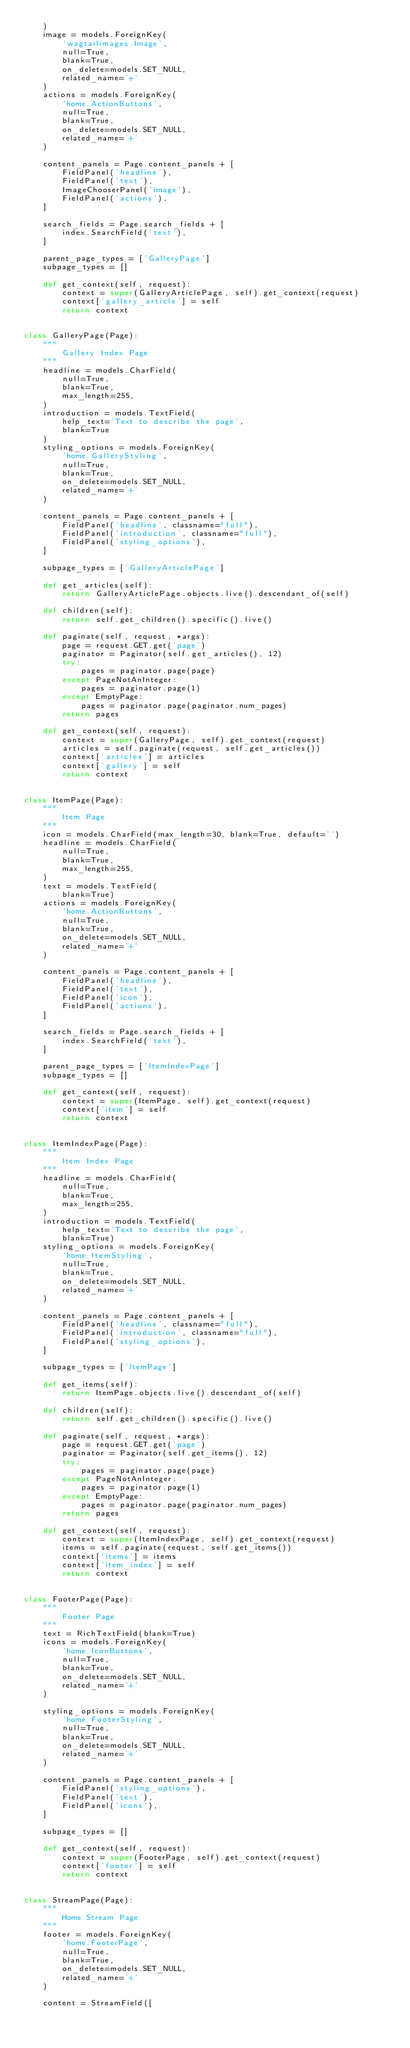<code> <loc_0><loc_0><loc_500><loc_500><_Python_>    )
    image = models.ForeignKey(
        'wagtailimages.Image',
        null=True,
        blank=True,
        on_delete=models.SET_NULL,
        related_name='+'
    )
    actions = models.ForeignKey(
        'home.ActionButtons',
        null=True,
        blank=True,
        on_delete=models.SET_NULL,
        related_name='+'
    )

    content_panels = Page.content_panels + [
        FieldPanel('headline'),
        FieldPanel('text'),
        ImageChooserPanel('image'),
        FieldPanel('actions'),
    ]

    search_fields = Page.search_fields + [
        index.SearchField('text'),
    ]

    parent_page_types = ['GalleryPage']
    subpage_types = []

    def get_context(self, request):
        context = super(GalleryArticlePage, self).get_context(request)
        context['gallery_article'] = self
        return context


class GalleryPage(Page):
    """
        Gallery Index Page
    """
    headline = models.CharField(
        null=True,
        blank=True,
        max_length=255,
    )
    introduction = models.TextField(
        help_text='Text to describe the page',
        blank=True
    )
    styling_options = models.ForeignKey(
        'home.GalleryStyling',
        null=True,
        blank=True,
        on_delete=models.SET_NULL,
        related_name='+'
    )

    content_panels = Page.content_panels + [
        FieldPanel('headline', classname="full"),
        FieldPanel('introduction', classname="full"),
        FieldPanel('styling_options'),
    ]

    subpage_types = ['GalleryArticlePage']

    def get_articles(self):
        return GalleryArticlePage.objects.live().descendant_of(self)

    def children(self):
        return self.get_children().specific().live()

    def paginate(self, request, *args):
        page = request.GET.get('page')
        paginator = Paginator(self.get_articles(), 12)
        try:
            pages = paginator.page(page)
        except PageNotAnInteger:
            pages = paginator.page(1)
        except EmptyPage:
            pages = paginator.page(paginator.num_pages)
        return pages

    def get_context(self, request):
        context = super(GalleryPage, self).get_context(request)
        articles = self.paginate(request, self.get_articles())
        context['articles'] = articles
        context['gallery'] = self
        return context


class ItemPage(Page):
    """
        Item Page
    """
    icon = models.CharField(max_length=30, blank=True, default='')
    headline = models.CharField(
        null=True,
        blank=True,
        max_length=255,
    )
    text = models.TextField(
        blank=True)
    actions = models.ForeignKey(
        'home.ActionButtons',
        null=True,
        blank=True,
        on_delete=models.SET_NULL,
        related_name='+'
    )

    content_panels = Page.content_panels + [
        FieldPanel('headline'),
        FieldPanel('text'),
        FieldPanel('icon'),
        FieldPanel('actions'),
    ]

    search_fields = Page.search_fields + [
        index.SearchField('text'),
    ]

    parent_page_types = ['ItemIndexPage']
    subpage_types = []

    def get_context(self, request):
        context = super(ItemPage, self).get_context(request)
        context['item'] = self
        return context


class ItemIndexPage(Page):
    """
        Item Index Page
    """
    headline = models.CharField(
        null=True,
        blank=True,
        max_length=255,
    )
    introduction = models.TextField(
        help_text='Text to describe the page',
        blank=True)
    styling_options = models.ForeignKey(
        'home.ItemStyling',
        null=True,
        blank=True,
        on_delete=models.SET_NULL,
        related_name='+'
    )

    content_panels = Page.content_panels + [
        FieldPanel('headline', classname="full"),
        FieldPanel('introduction', classname="full"),
        FieldPanel('styling_options'),
    ]

    subpage_types = ['ItemPage']

    def get_items(self):
        return ItemPage.objects.live().descendant_of(self)

    def children(self):
        return self.get_children().specific().live()

    def paginate(self, request, *args):
        page = request.GET.get('page')
        paginator = Paginator(self.get_items(), 12)
        try:
            pages = paginator.page(page)
        except PageNotAnInteger:
            pages = paginator.page(1)
        except EmptyPage:
            pages = paginator.page(paginator.num_pages)
        return pages

    def get_context(self, request):
        context = super(ItemIndexPage, self).get_context(request)
        items = self.paginate(request, self.get_items())
        context['items'] = items
        context['item_index'] = self
        return context


class FooterPage(Page):
    """
        Footer Page
    """
    text = RichTextField(blank=True)
    icons = models.ForeignKey(
        'home.IconButtons',
        null=True,
        blank=True,
        on_delete=models.SET_NULL,
        related_name='+'
    )

    styling_options = models.ForeignKey(
        'home.FooterStyling',
        null=True,
        blank=True,
        on_delete=models.SET_NULL,
        related_name='+'
    )

    content_panels = Page.content_panels + [
        FieldPanel('styling_options'),
        FieldPanel('text'),
        FieldPanel('icons'),
    ]

    subpage_types = []

    def get_context(self, request):
        context = super(FooterPage, self).get_context(request)
        context['footer'] = self
        return context


class StreamPage(Page):
    """
        Home Stream Page
    """
    footer = models.ForeignKey(
        'home.FooterPage',
        null=True,
        blank=True,
        on_delete=models.SET_NULL,
        related_name='+'
    )

    content = StreamField([</code> 